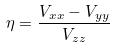Convert formula to latex. <formula><loc_0><loc_0><loc_500><loc_500>\eta = \frac { V _ { x x } - V _ { y y } } { V _ { z z } }</formula> 